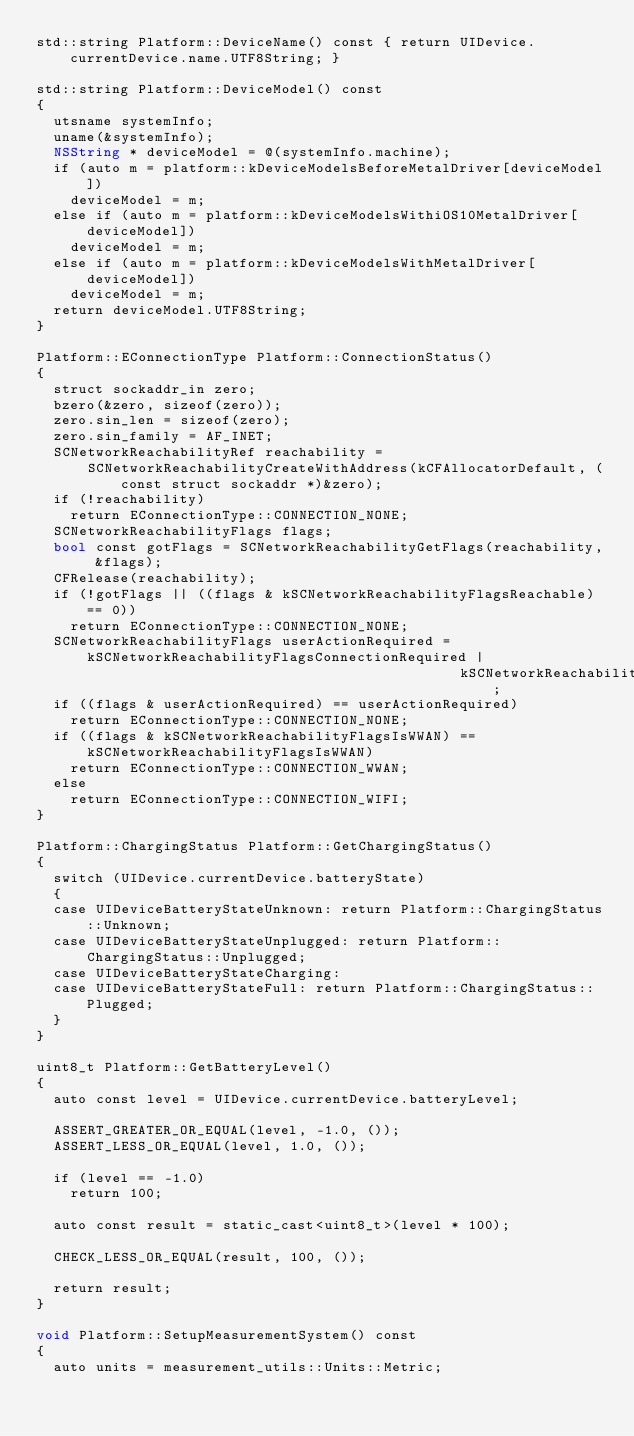<code> <loc_0><loc_0><loc_500><loc_500><_ObjectiveC_>std::string Platform::DeviceName() const { return UIDevice.currentDevice.name.UTF8String; }

std::string Platform::DeviceModel() const
{
  utsname systemInfo;
  uname(&systemInfo);
  NSString * deviceModel = @(systemInfo.machine);
  if (auto m = platform::kDeviceModelsBeforeMetalDriver[deviceModel])
    deviceModel = m;
  else if (auto m = platform::kDeviceModelsWithiOS10MetalDriver[deviceModel])
    deviceModel = m;
  else if (auto m = platform::kDeviceModelsWithMetalDriver[deviceModel])
    deviceModel = m;
  return deviceModel.UTF8String;
}

Platform::EConnectionType Platform::ConnectionStatus()
{
  struct sockaddr_in zero;
  bzero(&zero, sizeof(zero));
  zero.sin_len = sizeof(zero);
  zero.sin_family = AF_INET;
  SCNetworkReachabilityRef reachability =
      SCNetworkReachabilityCreateWithAddress(kCFAllocatorDefault, (const struct sockaddr *)&zero);
  if (!reachability)
    return EConnectionType::CONNECTION_NONE;
  SCNetworkReachabilityFlags flags;
  bool const gotFlags = SCNetworkReachabilityGetFlags(reachability, &flags);
  CFRelease(reachability);
  if (!gotFlags || ((flags & kSCNetworkReachabilityFlagsReachable) == 0))
    return EConnectionType::CONNECTION_NONE;
  SCNetworkReachabilityFlags userActionRequired = kSCNetworkReachabilityFlagsConnectionRequired |
                                                  kSCNetworkReachabilityFlagsInterventionRequired;
  if ((flags & userActionRequired) == userActionRequired)
    return EConnectionType::CONNECTION_NONE;
  if ((flags & kSCNetworkReachabilityFlagsIsWWAN) == kSCNetworkReachabilityFlagsIsWWAN)
    return EConnectionType::CONNECTION_WWAN;
  else
    return EConnectionType::CONNECTION_WIFI;
}

Platform::ChargingStatus Platform::GetChargingStatus()
{
  switch (UIDevice.currentDevice.batteryState)
  {
  case UIDeviceBatteryStateUnknown: return Platform::ChargingStatus::Unknown;
  case UIDeviceBatteryStateUnplugged: return Platform::ChargingStatus::Unplugged;
  case UIDeviceBatteryStateCharging:
  case UIDeviceBatteryStateFull: return Platform::ChargingStatus::Plugged;
  }
}

uint8_t Platform::GetBatteryLevel()
{
  auto const level = UIDevice.currentDevice.batteryLevel;

  ASSERT_GREATER_OR_EQUAL(level, -1.0, ());
  ASSERT_LESS_OR_EQUAL(level, 1.0, ());

  if (level == -1.0)
    return 100;

  auto const result = static_cast<uint8_t>(level * 100);

  CHECK_LESS_OR_EQUAL(result, 100, ());

  return result;
}

void Platform::SetupMeasurementSystem() const
{
  auto units = measurement_utils::Units::Metric;</code> 